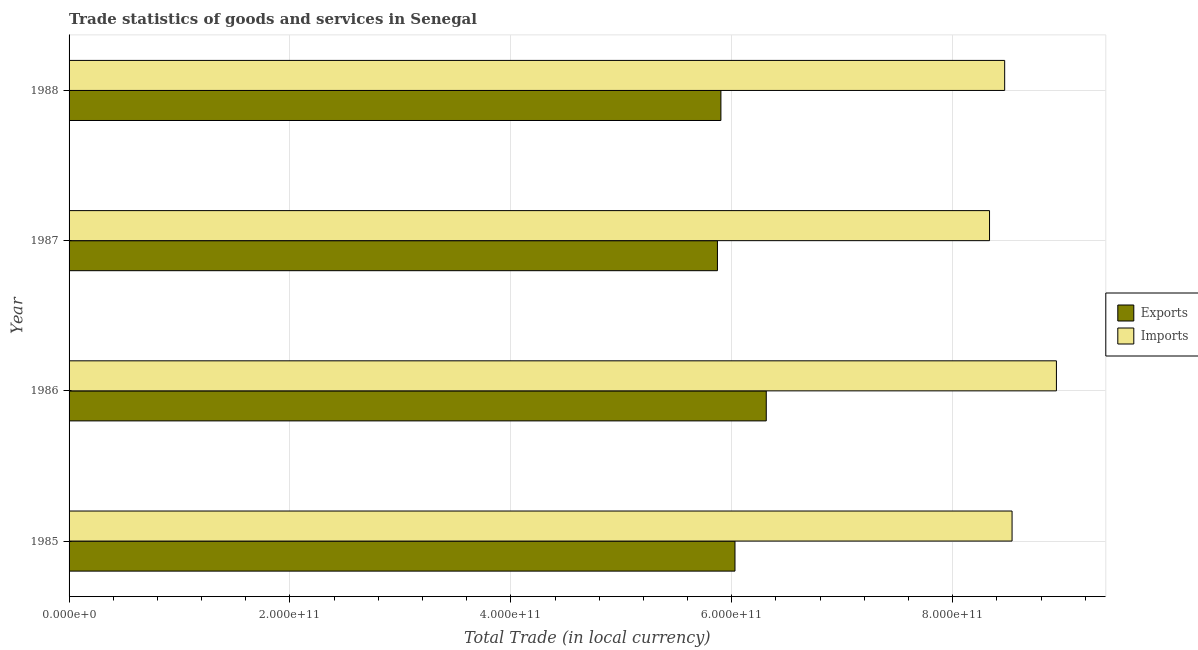How many different coloured bars are there?
Ensure brevity in your answer.  2. Are the number of bars per tick equal to the number of legend labels?
Keep it short and to the point. Yes. How many bars are there on the 4th tick from the top?
Your answer should be very brief. 2. How many bars are there on the 1st tick from the bottom?
Your answer should be very brief. 2. In how many cases, is the number of bars for a given year not equal to the number of legend labels?
Ensure brevity in your answer.  0. What is the export of goods and services in 1986?
Ensure brevity in your answer.  6.31e+11. Across all years, what is the maximum export of goods and services?
Give a very brief answer. 6.31e+11. Across all years, what is the minimum export of goods and services?
Give a very brief answer. 5.87e+11. In which year was the imports of goods and services maximum?
Make the answer very short. 1986. In which year was the export of goods and services minimum?
Offer a terse response. 1987. What is the total imports of goods and services in the graph?
Give a very brief answer. 3.43e+12. What is the difference between the imports of goods and services in 1987 and that in 1988?
Offer a very short reply. -1.37e+1. What is the difference between the export of goods and services in 1985 and the imports of goods and services in 1988?
Offer a terse response. -2.44e+11. What is the average imports of goods and services per year?
Ensure brevity in your answer.  8.57e+11. In the year 1987, what is the difference between the imports of goods and services and export of goods and services?
Provide a short and direct response. 2.46e+11. In how many years, is the export of goods and services greater than 120000000000 LCU?
Your answer should be very brief. 4. What is the ratio of the export of goods and services in 1986 to that in 1987?
Offer a very short reply. 1.07. Is the imports of goods and services in 1985 less than that in 1988?
Offer a very short reply. No. What is the difference between the highest and the second highest export of goods and services?
Ensure brevity in your answer.  2.83e+1. What is the difference between the highest and the lowest export of goods and services?
Offer a terse response. 4.42e+1. What does the 2nd bar from the top in 1985 represents?
Offer a terse response. Exports. What does the 2nd bar from the bottom in 1988 represents?
Your response must be concise. Imports. How many bars are there?
Offer a very short reply. 8. Are all the bars in the graph horizontal?
Ensure brevity in your answer.  Yes. How many years are there in the graph?
Offer a terse response. 4. What is the difference between two consecutive major ticks on the X-axis?
Provide a short and direct response. 2.00e+11. Are the values on the major ticks of X-axis written in scientific E-notation?
Provide a short and direct response. Yes. How many legend labels are there?
Your answer should be compact. 2. How are the legend labels stacked?
Keep it short and to the point. Vertical. What is the title of the graph?
Provide a short and direct response. Trade statistics of goods and services in Senegal. What is the label or title of the X-axis?
Offer a terse response. Total Trade (in local currency). What is the Total Trade (in local currency) of Exports in 1985?
Offer a terse response. 6.03e+11. What is the Total Trade (in local currency) in Imports in 1985?
Your answer should be very brief. 8.54e+11. What is the Total Trade (in local currency) of Exports in 1986?
Offer a terse response. 6.31e+11. What is the Total Trade (in local currency) in Imports in 1986?
Your answer should be compact. 8.94e+11. What is the Total Trade (in local currency) of Exports in 1987?
Your response must be concise. 5.87e+11. What is the Total Trade (in local currency) of Imports in 1987?
Ensure brevity in your answer.  8.33e+11. What is the Total Trade (in local currency) of Exports in 1988?
Ensure brevity in your answer.  5.90e+11. What is the Total Trade (in local currency) of Imports in 1988?
Your answer should be compact. 8.47e+11. Across all years, what is the maximum Total Trade (in local currency) in Exports?
Make the answer very short. 6.31e+11. Across all years, what is the maximum Total Trade (in local currency) in Imports?
Keep it short and to the point. 8.94e+11. Across all years, what is the minimum Total Trade (in local currency) in Exports?
Make the answer very short. 5.87e+11. Across all years, what is the minimum Total Trade (in local currency) in Imports?
Your answer should be compact. 8.33e+11. What is the total Total Trade (in local currency) in Exports in the graph?
Keep it short and to the point. 2.41e+12. What is the total Total Trade (in local currency) of Imports in the graph?
Provide a succinct answer. 3.43e+12. What is the difference between the Total Trade (in local currency) of Exports in 1985 and that in 1986?
Make the answer very short. -2.83e+1. What is the difference between the Total Trade (in local currency) in Imports in 1985 and that in 1986?
Your response must be concise. -4.02e+1. What is the difference between the Total Trade (in local currency) in Exports in 1985 and that in 1987?
Offer a terse response. 1.59e+1. What is the difference between the Total Trade (in local currency) in Imports in 1985 and that in 1987?
Your answer should be very brief. 2.04e+1. What is the difference between the Total Trade (in local currency) in Exports in 1985 and that in 1988?
Offer a terse response. 1.27e+1. What is the difference between the Total Trade (in local currency) of Imports in 1985 and that in 1988?
Offer a very short reply. 6.70e+09. What is the difference between the Total Trade (in local currency) of Exports in 1986 and that in 1987?
Make the answer very short. 4.42e+1. What is the difference between the Total Trade (in local currency) of Imports in 1986 and that in 1987?
Offer a very short reply. 6.06e+1. What is the difference between the Total Trade (in local currency) in Exports in 1986 and that in 1988?
Make the answer very short. 4.11e+1. What is the difference between the Total Trade (in local currency) in Imports in 1986 and that in 1988?
Make the answer very short. 4.69e+1. What is the difference between the Total Trade (in local currency) of Exports in 1987 and that in 1988?
Offer a terse response. -3.15e+09. What is the difference between the Total Trade (in local currency) of Imports in 1987 and that in 1988?
Keep it short and to the point. -1.37e+1. What is the difference between the Total Trade (in local currency) of Exports in 1985 and the Total Trade (in local currency) of Imports in 1986?
Ensure brevity in your answer.  -2.91e+11. What is the difference between the Total Trade (in local currency) in Exports in 1985 and the Total Trade (in local currency) in Imports in 1987?
Give a very brief answer. -2.30e+11. What is the difference between the Total Trade (in local currency) in Exports in 1985 and the Total Trade (in local currency) in Imports in 1988?
Offer a very short reply. -2.44e+11. What is the difference between the Total Trade (in local currency) in Exports in 1986 and the Total Trade (in local currency) in Imports in 1987?
Your response must be concise. -2.02e+11. What is the difference between the Total Trade (in local currency) in Exports in 1986 and the Total Trade (in local currency) in Imports in 1988?
Offer a very short reply. -2.16e+11. What is the difference between the Total Trade (in local currency) of Exports in 1987 and the Total Trade (in local currency) of Imports in 1988?
Offer a very short reply. -2.60e+11. What is the average Total Trade (in local currency) in Exports per year?
Offer a very short reply. 6.03e+11. What is the average Total Trade (in local currency) in Imports per year?
Your answer should be compact. 8.57e+11. In the year 1985, what is the difference between the Total Trade (in local currency) in Exports and Total Trade (in local currency) in Imports?
Offer a very short reply. -2.51e+11. In the year 1986, what is the difference between the Total Trade (in local currency) of Exports and Total Trade (in local currency) of Imports?
Ensure brevity in your answer.  -2.63e+11. In the year 1987, what is the difference between the Total Trade (in local currency) of Exports and Total Trade (in local currency) of Imports?
Provide a succinct answer. -2.46e+11. In the year 1988, what is the difference between the Total Trade (in local currency) of Exports and Total Trade (in local currency) of Imports?
Make the answer very short. -2.57e+11. What is the ratio of the Total Trade (in local currency) in Exports in 1985 to that in 1986?
Offer a terse response. 0.96. What is the ratio of the Total Trade (in local currency) of Imports in 1985 to that in 1986?
Ensure brevity in your answer.  0.96. What is the ratio of the Total Trade (in local currency) in Exports in 1985 to that in 1987?
Give a very brief answer. 1.03. What is the ratio of the Total Trade (in local currency) of Imports in 1985 to that in 1987?
Provide a succinct answer. 1.02. What is the ratio of the Total Trade (in local currency) in Exports in 1985 to that in 1988?
Keep it short and to the point. 1.02. What is the ratio of the Total Trade (in local currency) in Imports in 1985 to that in 1988?
Ensure brevity in your answer.  1.01. What is the ratio of the Total Trade (in local currency) in Exports in 1986 to that in 1987?
Your answer should be compact. 1.08. What is the ratio of the Total Trade (in local currency) in Imports in 1986 to that in 1987?
Make the answer very short. 1.07. What is the ratio of the Total Trade (in local currency) of Exports in 1986 to that in 1988?
Provide a short and direct response. 1.07. What is the ratio of the Total Trade (in local currency) in Imports in 1986 to that in 1988?
Provide a succinct answer. 1.06. What is the ratio of the Total Trade (in local currency) in Exports in 1987 to that in 1988?
Make the answer very short. 0.99. What is the ratio of the Total Trade (in local currency) of Imports in 1987 to that in 1988?
Ensure brevity in your answer.  0.98. What is the difference between the highest and the second highest Total Trade (in local currency) of Exports?
Offer a very short reply. 2.83e+1. What is the difference between the highest and the second highest Total Trade (in local currency) of Imports?
Your answer should be very brief. 4.02e+1. What is the difference between the highest and the lowest Total Trade (in local currency) in Exports?
Offer a terse response. 4.42e+1. What is the difference between the highest and the lowest Total Trade (in local currency) in Imports?
Offer a terse response. 6.06e+1. 